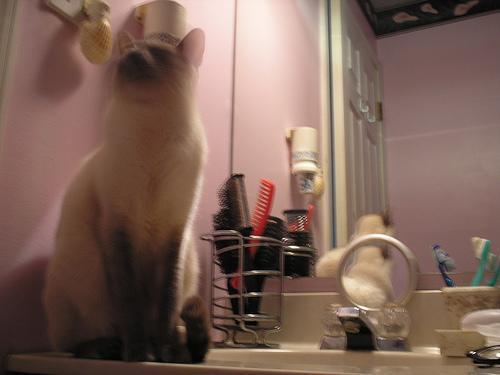How many toothbrushes are there?
Give a very brief answer. 2. 